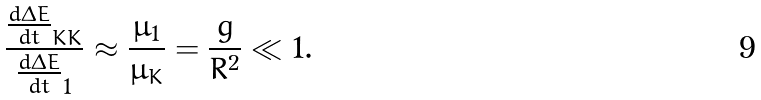Convert formula to latex. <formula><loc_0><loc_0><loc_500><loc_500>\frac { \frac { d \Delta E } { d t } _ { K K } } { \frac { d \Delta E } { d t } _ { 1 } } \approx \frac { \mu _ { 1 } } { \mu _ { K } } = \frac { g } { R ^ { 2 } } \ll 1 .</formula> 